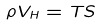Convert formula to latex. <formula><loc_0><loc_0><loc_500><loc_500>\rho V _ { H } = T S</formula> 